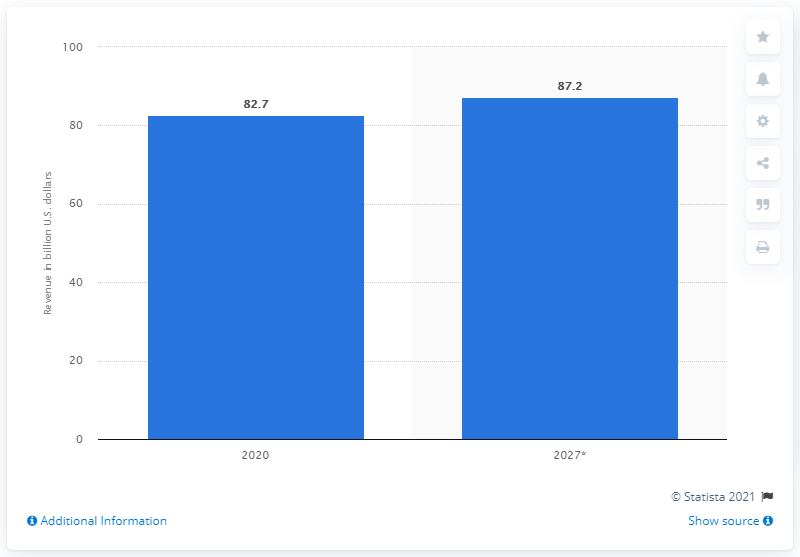Indicate a few pertinent items in this graphic. The global corporate wellness market is projected to expand at a significant rate, reaching an expected value of 87.2 by 2027. 